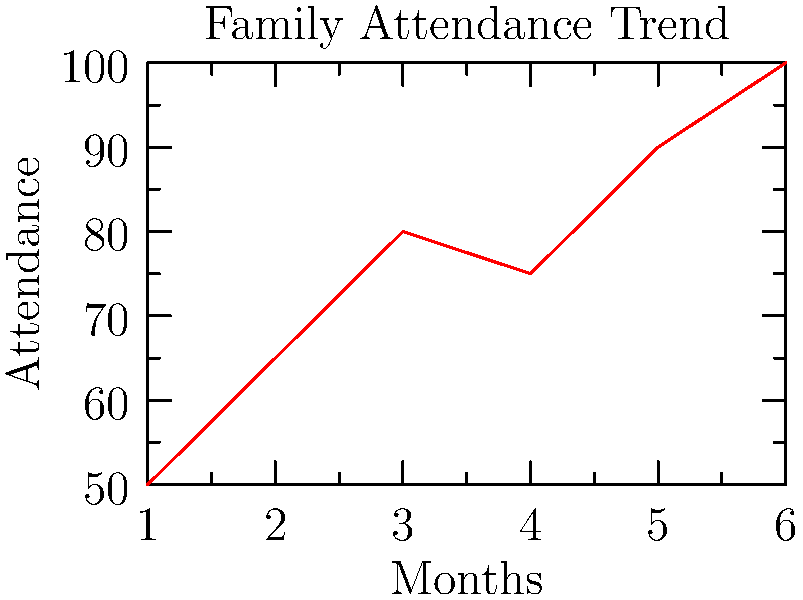As a youth group leader organizing family bonding events, you've been tracking attendance over the past 6 months. The line graph shows the trend in family attendance. What is the average increase in attendance per month? To find the average increase in attendance per month, we need to:

1. Calculate the total increase in attendance:
   Final attendance (Month 6) - Initial attendance (Month 1) = 100 - 50 = 50

2. Determine the number of intervals:
   There are 6 months, so there are 5 intervals between them.

3. Calculate the average increase per month:
   Average increase = Total increase ÷ Number of intervals
   $\frac{50}{5} = 10$

Therefore, the average increase in attendance per month is 10 families.
Answer: 10 families 